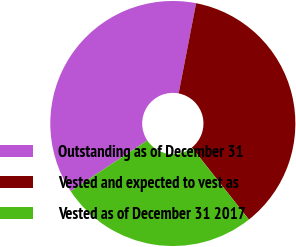Convert chart. <chart><loc_0><loc_0><loc_500><loc_500><pie_chart><fcel>Outstanding as of December 31<fcel>Vested and expected to vest as<fcel>Vested as of December 31 2017<nl><fcel>37.35%<fcel>36.3%<fcel>26.35%<nl></chart> 